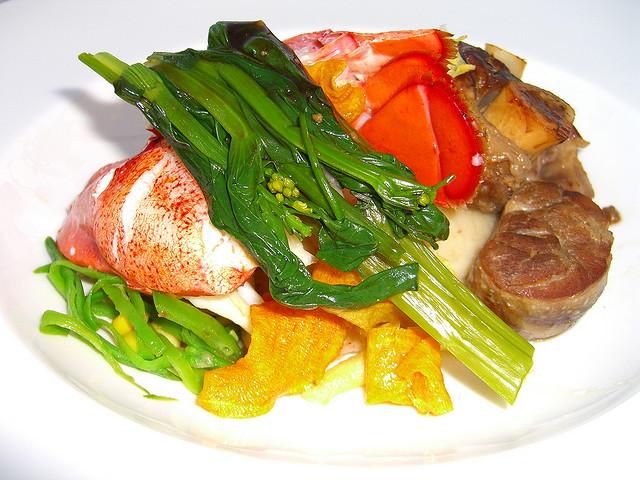What meat is served?
Concise answer only. Beef. Is the fork and knife next to the plate?
Answer briefly. No. What color is the plate?
Write a very short answer. White. 